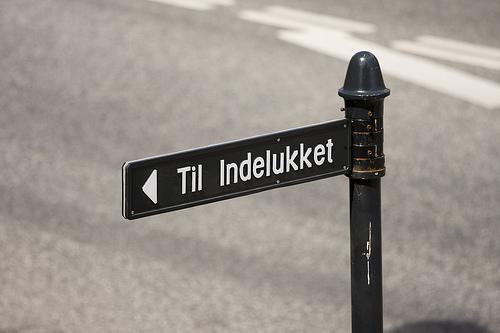Provide a vivid description of the signpost and its content in the image. The signpost is a black metal pole with a black sign featuring white letters that read, 'Til Indelukket.' It has a white arrow pointing to the left and is positioned on the side of a deserted asphalt road. What is the purpose of the white arrow mentioned in the details of the image? The white arrow serves as a visual guide to direct attention towards the left, indicating the direction of 'Til Indelukket.' Describe the pole supporting the sign in detail, mentioning its color and any noticeable features. The pole supporting the sign is black, tall, and thin, with some rusty dots and lines, an orange screw, a white scratch, and a domed cap on top. What is the primary focus of the image and what is it used for? The main focus of the image is a black signpost with white lettering, directing towards 'Til Indelukket', and an arrow on its end pointing to the left. From the given information, how could you describe the environment surrounding the signpost? The signpost is located on a deserted gray asphalt road with white line markings and a nearby paving with light and medium grays. Enumerate the objects featured in the image that pertain to the sign itself. The objects related to the sign include the black metal pole, the domed cap on top, the black sign with white lettering, and the white arrow. Based on the details provided, what is the condition of the pole supporting the sign? The condition of the pole is somewhat worn with noticeable rusty dots and lines, an orange screw, and a white scratch on its surface. Analyze the details provided and determine the state of the sign's surface. The surface of the sign has a prominent scratch, which indicates some wear and tear, but its lettering and arrow remain clearly visible. Explain the appearance of the street below the sign, mentioning the type of material and any markings present. The street is made of gray asphalt with white lines, including a thick white line and short double lines, and it merges with a thin line. 